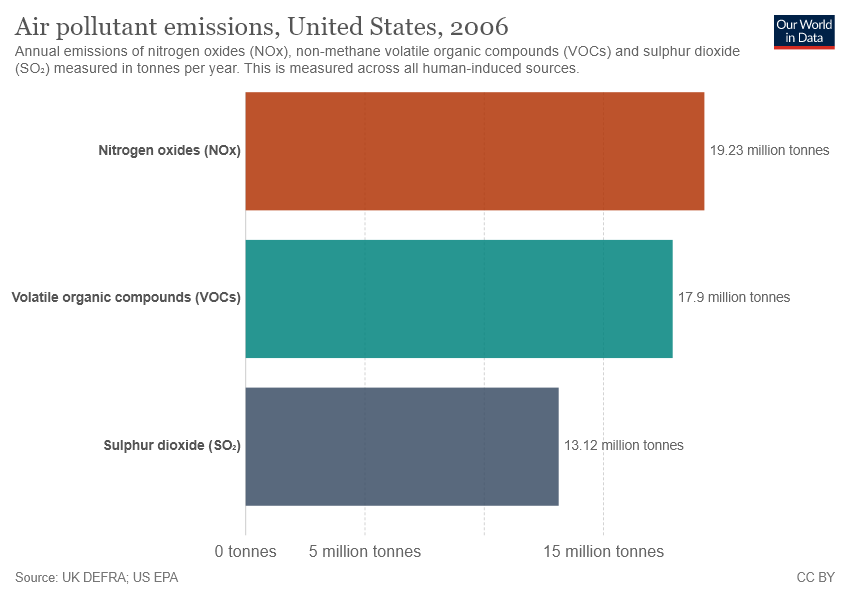Specify some key components in this picture. The Bar graph shows the emissions of different Air pollutants, and the Air pollutant with the highest emissions is Nitrogen oxides (NOx). The value of emissions from Volatile Organic Compounds is greater than Sulfur Dioxide. 